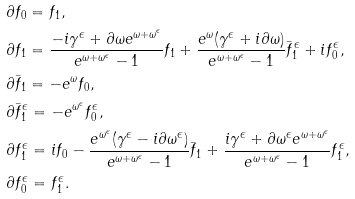<formula> <loc_0><loc_0><loc_500><loc_500>& \partial f _ { 0 } = f _ { 1 } , \\ & \partial f _ { 1 } = \frac { - i \gamma ^ { \epsilon } + \partial \omega e ^ { \omega + \omega ^ { \epsilon } } } { e ^ { \omega + \omega ^ { \epsilon } } - 1 } f _ { 1 } + \frac { e ^ { \omega } ( \gamma ^ { \epsilon } + i \partial \omega ) } { e ^ { \omega + \omega ^ { \epsilon } } - 1 } \bar { f } _ { 1 } ^ { \epsilon } + i f _ { 0 } ^ { \epsilon } , \\ & \partial \bar { f } _ { 1 } = - e ^ { \omega } f _ { 0 } , \\ & \partial \bar { f } _ { 1 } ^ { \epsilon } = - e ^ { \omega ^ { \epsilon } } f _ { 0 } ^ { \epsilon } , \\ & \partial f _ { 1 } ^ { \epsilon } = i f _ { 0 } - \frac { e ^ { \omega ^ { \epsilon } } ( \gamma ^ { \epsilon } - i \partial \omega ^ { \epsilon } ) } { e ^ { \omega + \omega ^ { \epsilon } } - 1 } \bar { f } _ { 1 } + \frac { i \gamma ^ { \epsilon } + \partial \omega ^ { \epsilon } e ^ { \omega + \omega ^ { \epsilon } } } { e ^ { \omega + \omega ^ { \epsilon } } - 1 } f _ { 1 } ^ { \epsilon } , \\ & \partial f _ { 0 } ^ { \epsilon } = f _ { 1 } ^ { \epsilon } .</formula> 